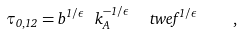<formula> <loc_0><loc_0><loc_500><loc_500>\tau _ { 0 , 1 2 } = b ^ { 1 / \epsilon } \ k _ { A } ^ { - 1 / \epsilon } \ \ t w e f ^ { 1 / \epsilon } \quad ,</formula> 